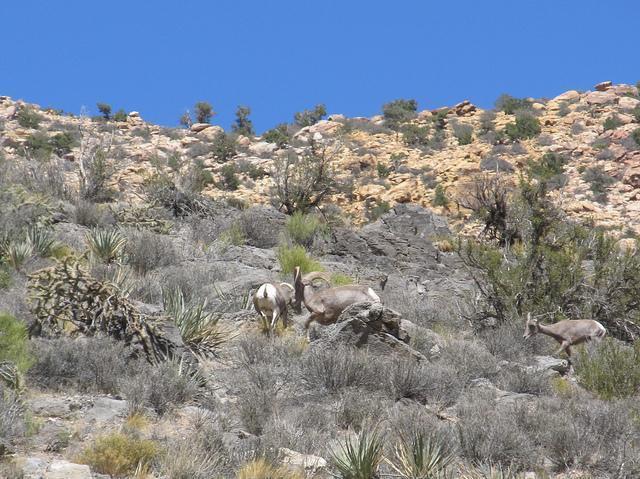What does the sky depict about the weather?
From the following set of four choices, select the accurate answer to respond to the question.
Options: Clear, cloudy, rainy, foggy. Clear. 